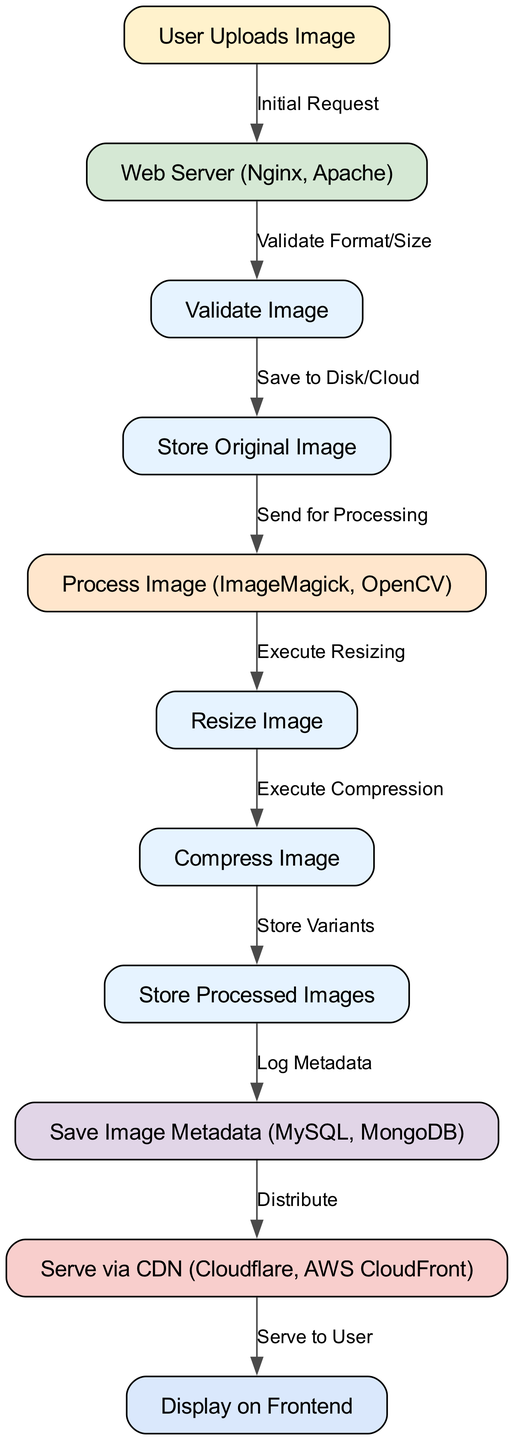What is the first step in the image processing workflow? The first step is indicated by the node "User Uploads Image," which represents the user's action of uploading an image. This is the initial point of the diagram where the workflow begins.
Answer: User Uploads Image How many nodes are present in the diagram? The diagram contains 11 nodes, each representing a specific step in the image processing workflow, from image upload to display on the frontend.
Answer: 11 What does the "Validation" node do? The "Validation" node is responsible for checking the format and size of the uploaded image to ensure it meets the requirements before further processing.
Answer: Validate Format/Size Which node follows the "Processing Engine"? After the "Processing Engine," the next node is "Resize Image," indicating that resizing is one of the immediate steps performed after processing the image.
Answer: Resize Image What is the final output in the workflow? The final output is shown in the "Display on Frontend" node, which represents the last step in the workflow where the processed image is served to the user.
Answer: Display on Frontend Describe the relationship between "Store Variants" and "Save Image Metadata". The "Store Variants" node is directly connected to "Save Image Metadata," indicating that after the processed images are stored, their corresponding metadata is logged in the database.
Answer: Store Processed Images What type of server is used in the workflow? The diagram specifies the use of "Web Server (Nginx, Apache)" as the type of server handling the initial image upload request.
Answer: Web Server (Nginx, Apache) Name the last integration point before serving the image to the user. The last integration point before the image is served is "Serve via CDN (Cloudflare, AWS CloudFront)," which distributes the processed images for efficient delivery.
Answer: Serve via CDN (Cloudflare, AWS CloudFront) 